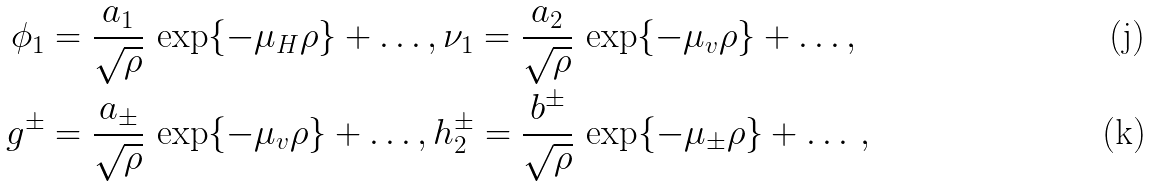Convert formula to latex. <formula><loc_0><loc_0><loc_500><loc_500>\phi _ { 1 } & = \frac { a _ { 1 } } { \sqrt { \rho } } \, \exp \{ - \mu _ { H } \rho \} + \dots , \nu _ { 1 } = \frac { a _ { 2 } } { \sqrt { \rho } } \, \exp \{ - \mu _ { v } \rho \} + \dots , \\ g ^ { \pm } & = \frac { a _ { \pm } } { \sqrt { \rho } } \, \exp \{ - \mu _ { v } \rho \} + \dots , h _ { 2 } ^ { \pm } = \frac { b ^ { \pm } } { \sqrt { \rho } } \, \exp \{ - \mu _ { \pm } \rho \} + \dots \, ,</formula> 